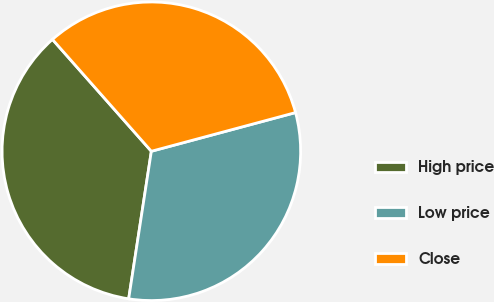Convert chart to OTSL. <chart><loc_0><loc_0><loc_500><loc_500><pie_chart><fcel>High price<fcel>Low price<fcel>Close<nl><fcel>36.05%<fcel>31.6%<fcel>32.35%<nl></chart> 